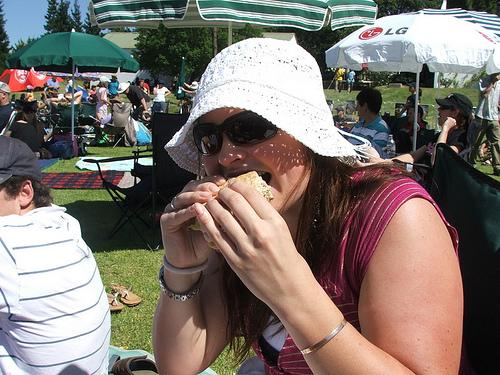What is the woman doing with the object in her hand? eating 